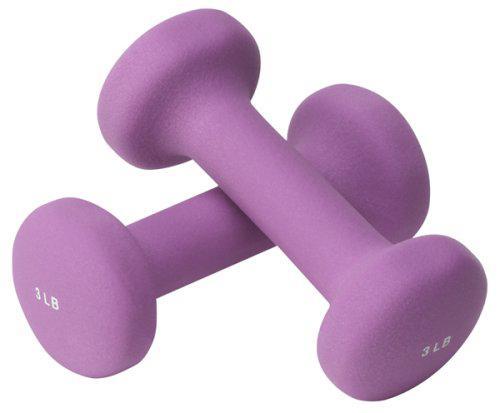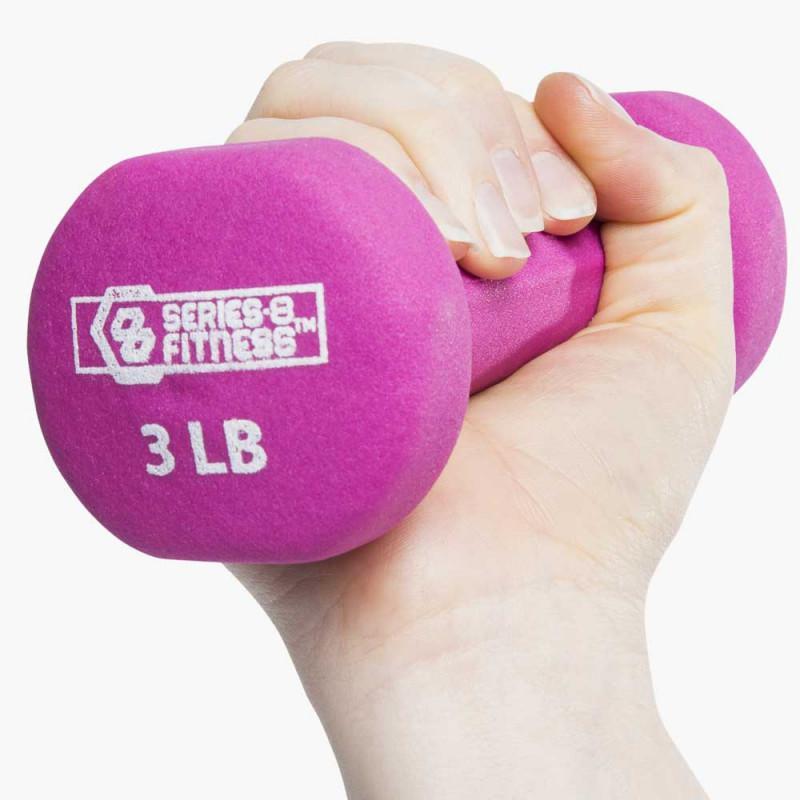The first image is the image on the left, the second image is the image on the right. Given the left and right images, does the statement "The right image shows a pair of pink free weights with one weight resting slightly atop the other" hold true? Answer yes or no. No. The first image is the image on the left, the second image is the image on the right. Evaluate the accuracy of this statement regarding the images: "The right image contains two small pink exercise weights.". Is it true? Answer yes or no. No. 